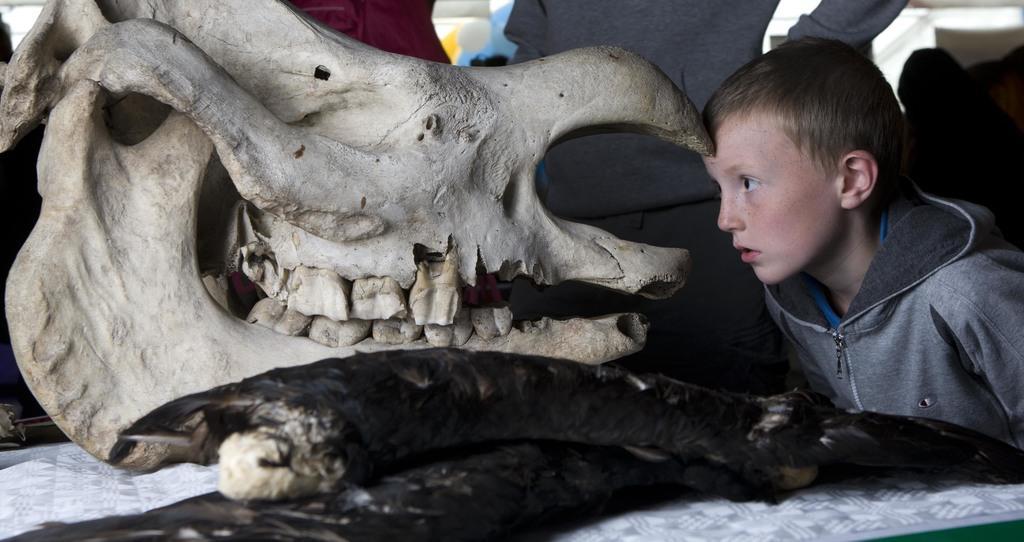How would you summarize this image in a sentence or two? On the left side of this image there is a skeleton of an animal which is placed on a white surface. On the right side there is a boy wearing a jacket and looking at the skeleton. In the background, I can see some more people. 